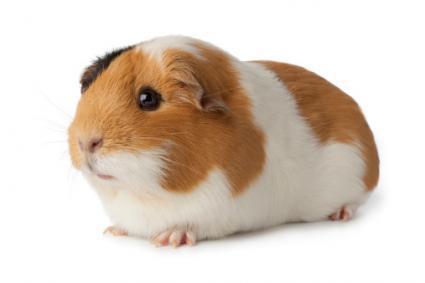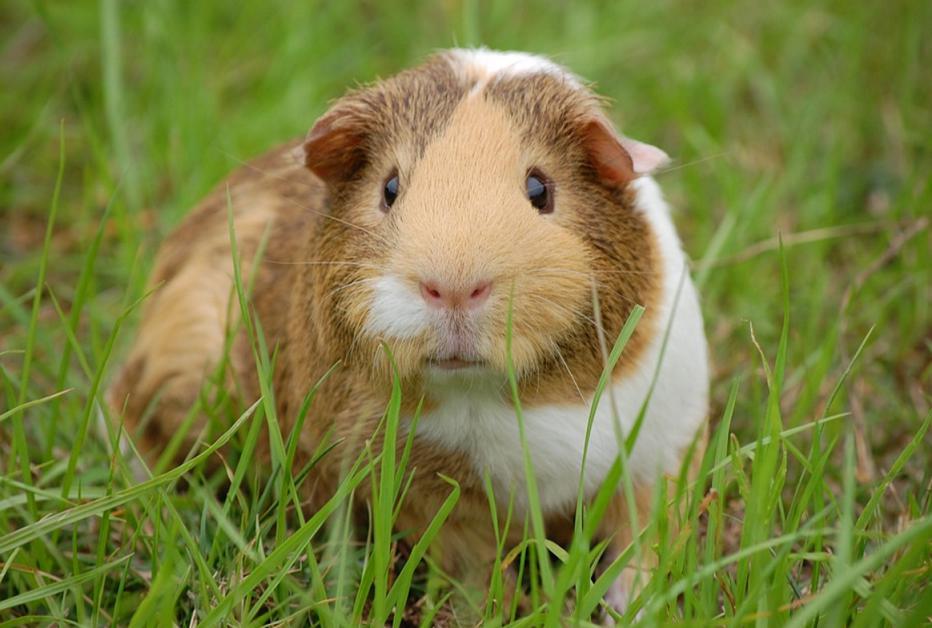The first image is the image on the left, the second image is the image on the right. For the images shown, is this caption "There are two hamsters." true? Answer yes or no. Yes. 